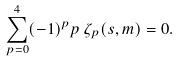<formula> <loc_0><loc_0><loc_500><loc_500>\sum _ { p = 0 } ^ { 4 } ( - 1 ) ^ { p } p \, \zeta _ { p } ( s , m ) = 0 .</formula> 